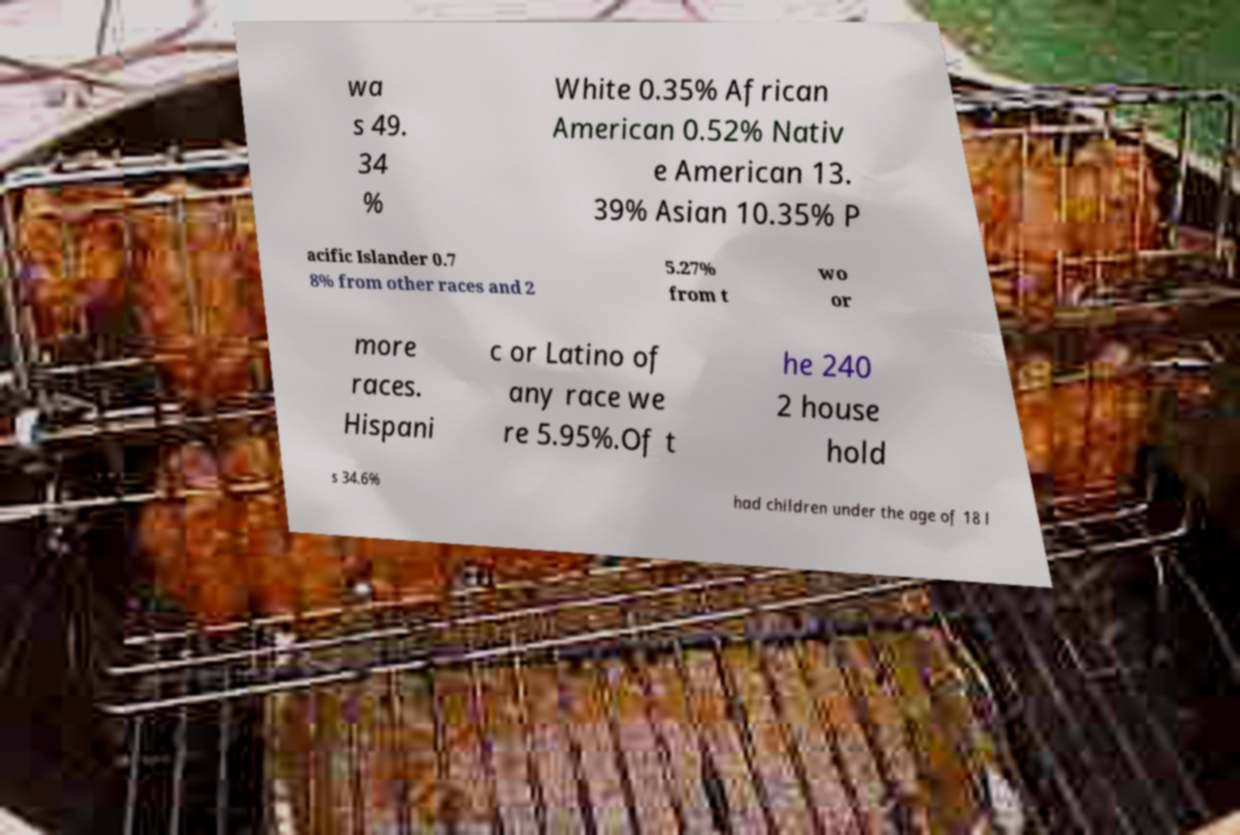Could you assist in decoding the text presented in this image and type it out clearly? wa s 49. 34 % White 0.35% African American 0.52% Nativ e American 13. 39% Asian 10.35% P acific Islander 0.7 8% from other races and 2 5.27% from t wo or more races. Hispani c or Latino of any race we re 5.95%.Of t he 240 2 house hold s 34.6% had children under the age of 18 l 